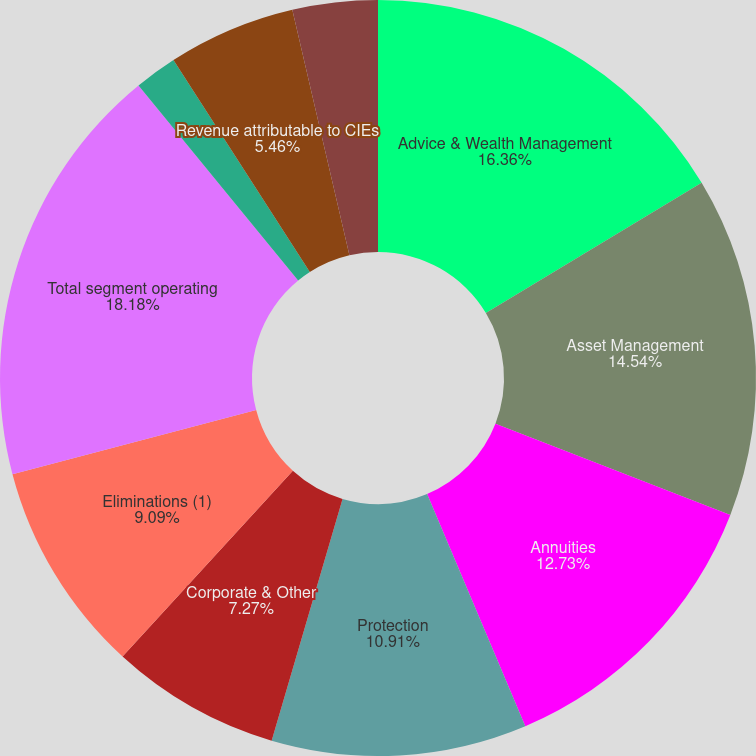Convert chart to OTSL. <chart><loc_0><loc_0><loc_500><loc_500><pie_chart><fcel>Advice & Wealth Management<fcel>Asset Management<fcel>Annuities<fcel>Protection<fcel>Corporate & Other<fcel>Eliminations (1)<fcel>Total segment operating<fcel>Net realized gains (losses)<fcel>Revenue attributable to CIEs<fcel>Market impact on IUL benefits<nl><fcel>16.36%<fcel>14.54%<fcel>12.73%<fcel>10.91%<fcel>7.27%<fcel>9.09%<fcel>18.18%<fcel>1.82%<fcel>5.46%<fcel>3.64%<nl></chart> 